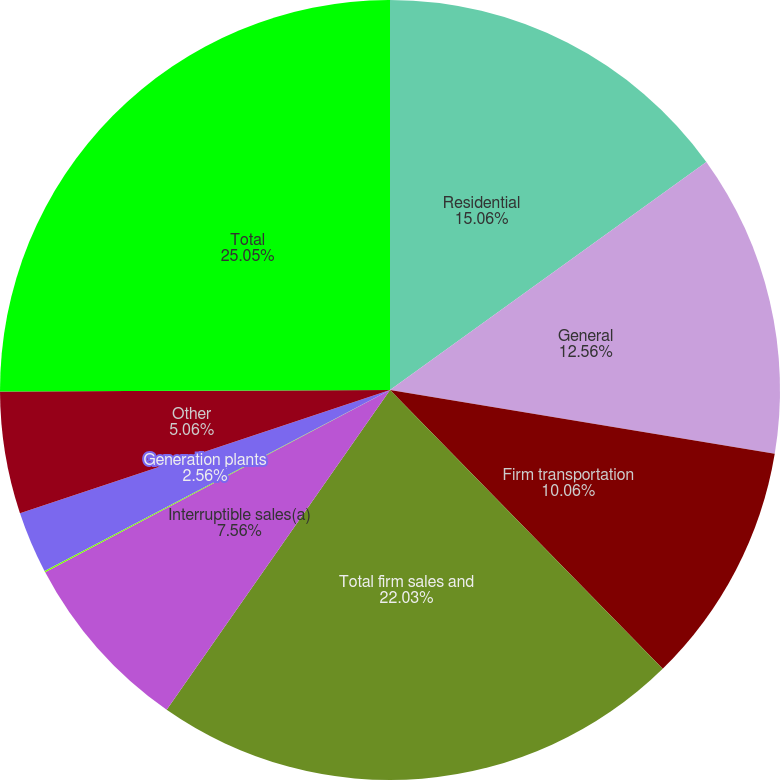<chart> <loc_0><loc_0><loc_500><loc_500><pie_chart><fcel>Residential<fcel>General<fcel>Firm transportation<fcel>Total firm sales and<fcel>Interruptible sales(a)<fcel>NYPA<fcel>Generation plants<fcel>Other<fcel>Total<nl><fcel>15.06%<fcel>12.56%<fcel>10.06%<fcel>22.03%<fcel>7.56%<fcel>0.06%<fcel>2.56%<fcel>5.06%<fcel>25.06%<nl></chart> 